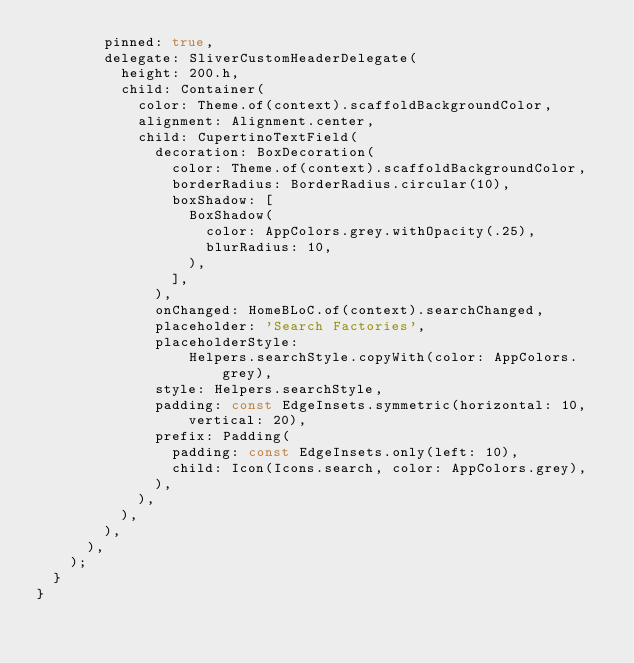<code> <loc_0><loc_0><loc_500><loc_500><_Dart_>        pinned: true,
        delegate: SliverCustomHeaderDelegate(
          height: 200.h,
          child: Container(
            color: Theme.of(context).scaffoldBackgroundColor,
            alignment: Alignment.center,
            child: CupertinoTextField(
              decoration: BoxDecoration(
                color: Theme.of(context).scaffoldBackgroundColor,
                borderRadius: BorderRadius.circular(10),
                boxShadow: [
                  BoxShadow(
                    color: AppColors.grey.withOpacity(.25),
                    blurRadius: 10,
                  ),
                ],
              ),
              onChanged: HomeBLoC.of(context).searchChanged,
              placeholder: 'Search Factories',
              placeholderStyle:
                  Helpers.searchStyle.copyWith(color: AppColors.grey),
              style: Helpers.searchStyle,
              padding: const EdgeInsets.symmetric(horizontal: 10, vertical: 20),
              prefix: Padding(
                padding: const EdgeInsets.only(left: 10),
                child: Icon(Icons.search, color: AppColors.grey),
              ),
            ),
          ),
        ),
      ),
    );
  }
}
</code> 